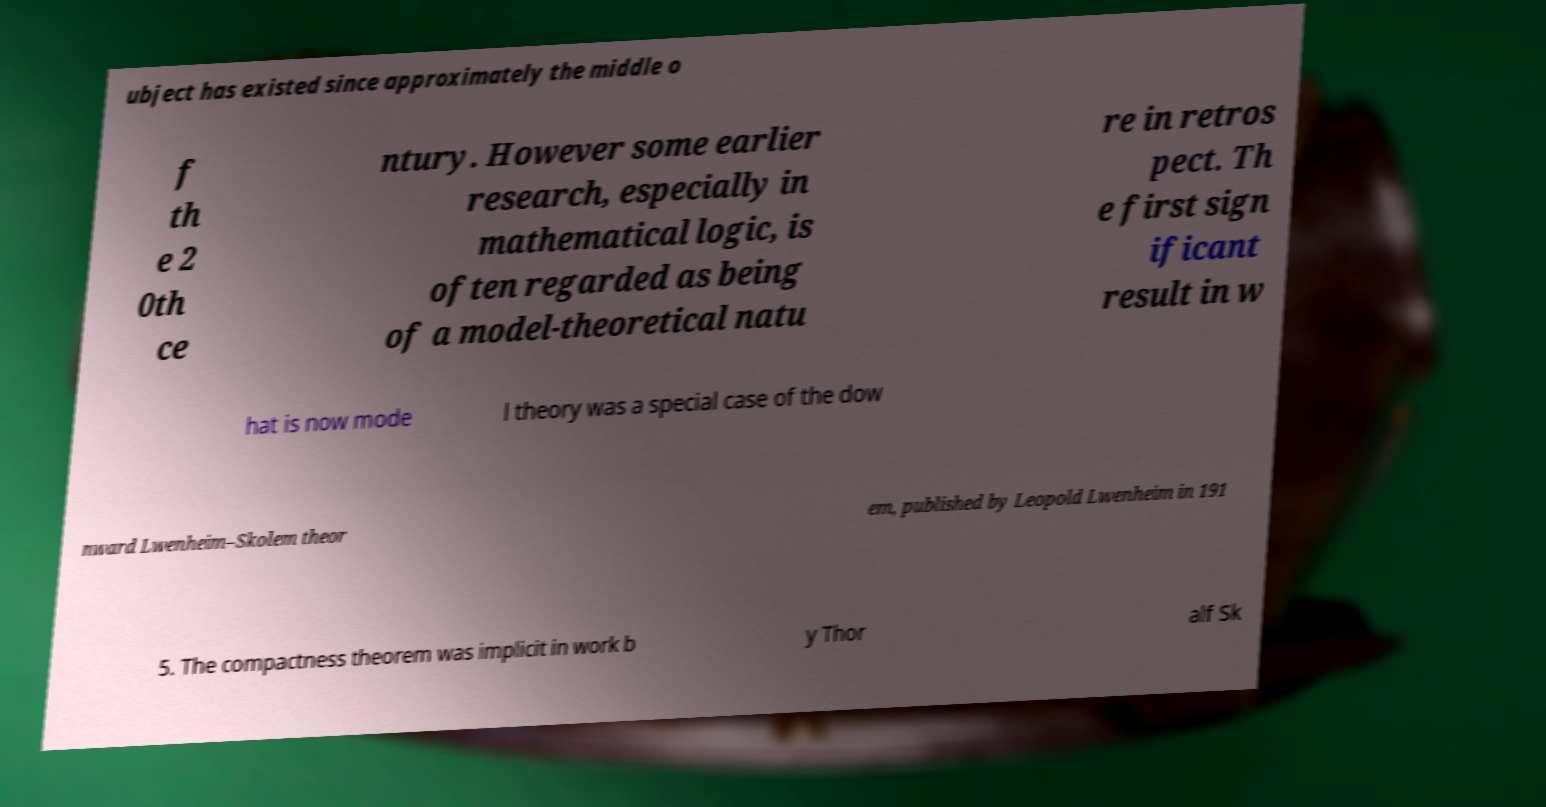Could you assist in decoding the text presented in this image and type it out clearly? ubject has existed since approximately the middle o f th e 2 0th ce ntury. However some earlier research, especially in mathematical logic, is often regarded as being of a model-theoretical natu re in retros pect. Th e first sign ificant result in w hat is now mode l theory was a special case of the dow nward Lwenheim–Skolem theor em, published by Leopold Lwenheim in 191 5. The compactness theorem was implicit in work b y Thor alf Sk 